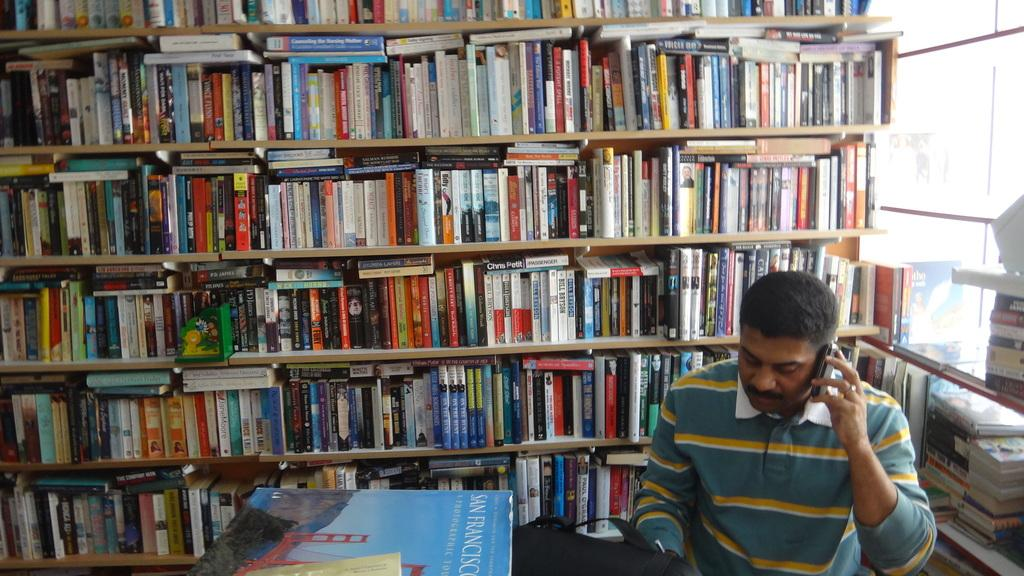<image>
Summarize the visual content of the image. the city San Francisco is on the blue table 